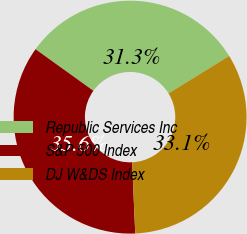Convert chart to OTSL. <chart><loc_0><loc_0><loc_500><loc_500><pie_chart><fcel>Republic Services Inc<fcel>S&P 500 Index<fcel>DJ W&DS Index<nl><fcel>31.28%<fcel>35.62%<fcel>33.1%<nl></chart> 